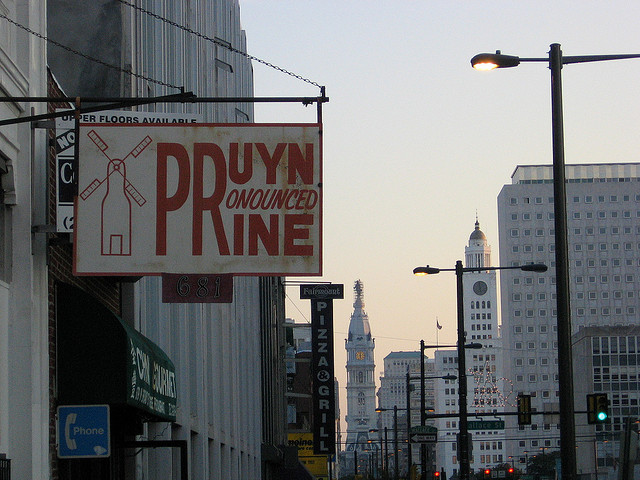<image>What tower is shown in the background? I don't know which tower is shown in the background. It could be a church, a clock tower, or the London Tower. What hotel/motel sign can be seen in the background? I am not sure. There is no clear hotel or motel sign in the background. What flowers are in the planters? There are no flowers in the planters. What country is written on the sign? I am not sure which country is written on the sign. The answers suggest 'Sweden', 'Pruyn', or 'Germany'. What hotel/motel sign can be seen in the background? The hotel/motel sign in the background cannot be determined. What tower is shown in the background? I don't know which tower is shown in the background. It can be the church tower, the London tower, the clock tower, or the prince tower. What flowers are in the planters? It is not clear what flowers are in the planters. There can be no flowers or different types of flowers. What country is written on the sign? I don't know what country is written on the sign. It can be seen 'pruyn', 'germany' or 'sweden'. 